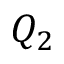Convert formula to latex. <formula><loc_0><loc_0><loc_500><loc_500>Q _ { 2 }</formula> 